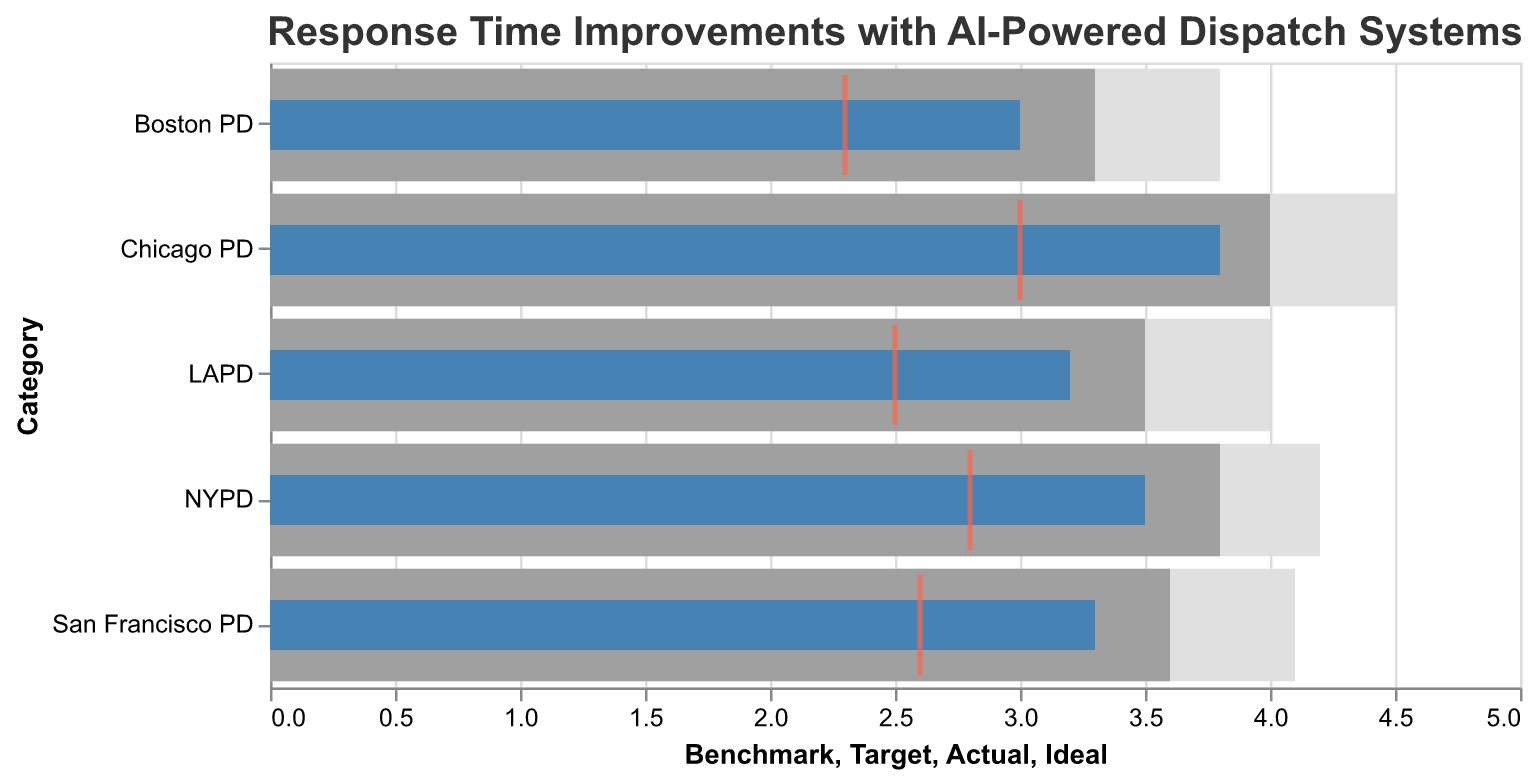What is the title of the figure? The title is displayed at the top of the figure, and it clearly reads "Response Time Improvements with AI-Powered Dispatch Systems".
Answer: Response Time Improvements with AI-Powered Dispatch Systems Which police department has the lowest actual response time? By looking at the "Actual" values, we can see that Boston PD has the lowest actual response time with a value of 3.0.
Answer: Boston PD How does the actual response time of Chicago PD compare to its benchmark? The actual response time for Chicago PD is 3.8, whereas the benchmark is 4.5. So, the actual response time is less than the benchmark.
Answer: Less than What is the average target response time across all categories? Adding all the target response times (3.5 + 3.8 + 4.0 + 3.3 + 3.6) gives 18.2, and dividing by the number of categories (5) gives 18.2/5 = 3.64.
Answer: 3.64 What are the colors of the bars representing the actual response times? The bars representing the actual response times are given a distinct color, specifically a shade of blue (like #4682B4).
Answer: Blue Which department's actual response time is closest to its ideal response time? By comparing the differences between actual and ideal response times: LAPD (3.2 - 2.5 = 0.7), NYPD (3.5 - 2.8 = 0.7), Chicago PD (3.8 - 3.0 = 0.8), Boston PD (3.0 - 2.3 = 0.7), and San Francisco PD (3.3 - 2.6 = 0.7). Several departments (LAPD, NYPD, Boston PD, and San Francisco PD) have the smallest difference of 0.7.
Answer: LAPD, NYPD, Boston PD, and San Francisco PD Which department has the largest gap between its actual and target response times? Calculating the differences: LAPD (3.5 - 3.2 = 0.3), NYPD (3.8 - 3.5 = 0.3), Chicago PD (4.0 - 3.8 = 0.2), Boston PD (3.3 - 3.0 = 0.3), and San Francisco PD (3.6 - 3.3 = 0.3). All departments except Chicago PD have a gap of 0.3.
Answer: LAPD, NYPD, Boston PD, and San Francisco PD What is the target response time for San Francisco PD? The target response time for San Francisco PD is shown as 3.6 in the dataset.
Answer: 3.6 How many police departments have an actual response time below their target response time? Comparing the actual and target response times for each department: LAPD (3.2 < 3.5), NYPD (3.5 < 3.8), Chicago PD (3.8 < 4.0), Boston PD (3.0 < 3.3), San Francisco PD (3.3 < 3.6). All five departments have actual response times below their targets.
Answer: 5 Which department's actual response time is the furthest from the ideal? Calculating the differences between actual and ideal response times: LAPD (0.7), NYPD (0.7), Chicago PD (0.8), Boston PD (0.7), San Francisco PD (0.7). Chicago PD has the largest difference, 0.8.
Answer: Chicago PD 